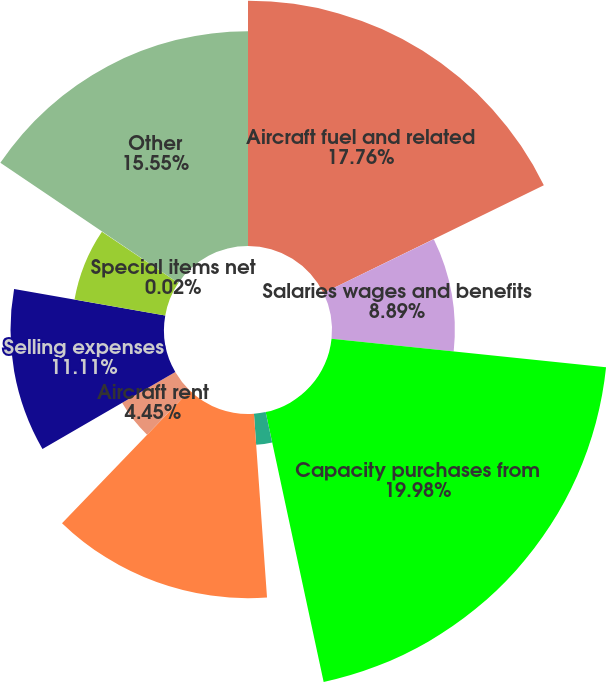Convert chart. <chart><loc_0><loc_0><loc_500><loc_500><pie_chart><fcel>Aircraft fuel and related<fcel>Salaries wages and benefits<fcel>Capacity purchases from<fcel>Maintenance materials and<fcel>Other rent and landing fees<fcel>Aircraft rent<fcel>Selling expenses<fcel>Depreciation and amortization<fcel>Special items net<fcel>Other<nl><fcel>17.76%<fcel>8.89%<fcel>19.98%<fcel>2.24%<fcel>13.33%<fcel>4.45%<fcel>11.11%<fcel>6.67%<fcel>0.02%<fcel>15.55%<nl></chart> 